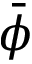Convert formula to latex. <formula><loc_0><loc_0><loc_500><loc_500>\bar { \phi }</formula> 